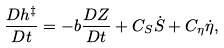Convert formula to latex. <formula><loc_0><loc_0><loc_500><loc_500>\frac { D h ^ { \ddag } } { D t } = - b \frac { D Z } { D t } + C _ { S } \dot { S } + C _ { \eta } \dot { \eta } ,</formula> 